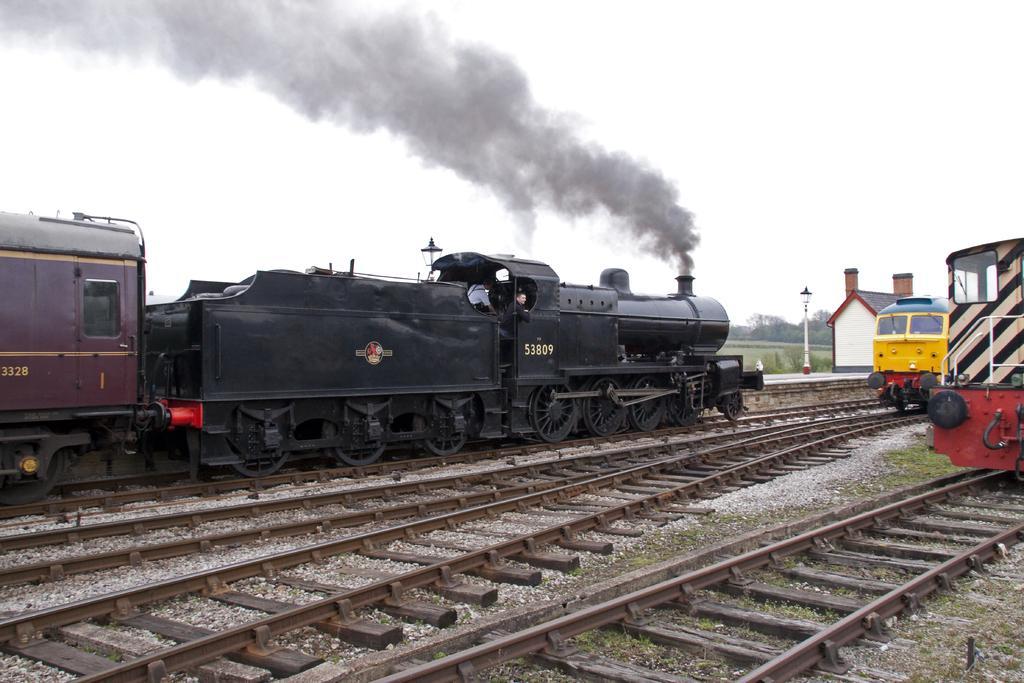Can you describe this image briefly? In the image we can see a train, on the train track. This is a grass, smoke, stones, light pole, tree and a sky. 